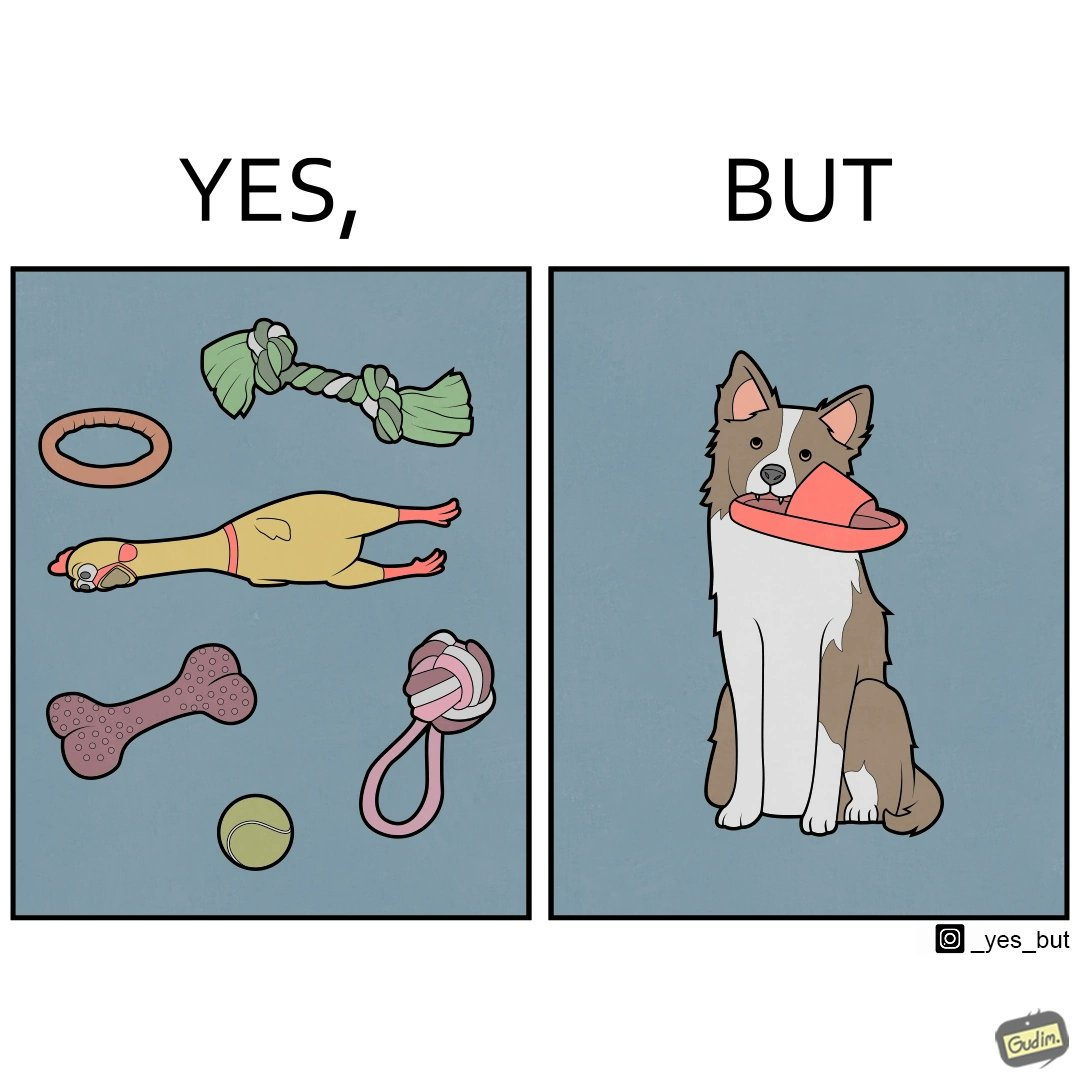Describe what you see in this image. The image is ironical, as even though the dog owner has bought toys for the dog, the dog is playing with a slipper in its mouth. 